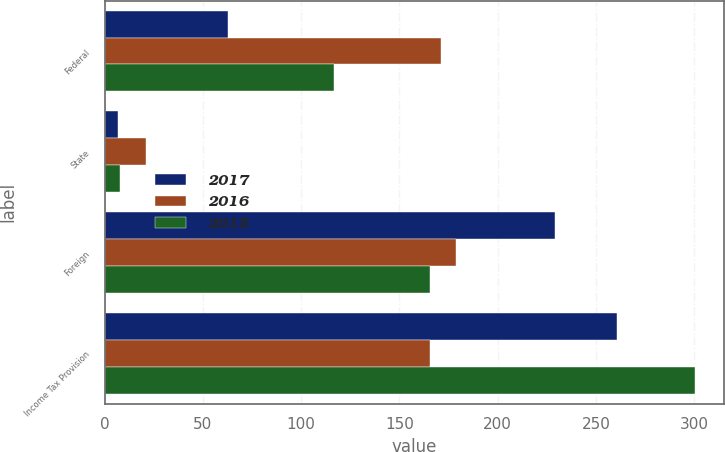Convert chart. <chart><loc_0><loc_0><loc_500><loc_500><stacked_bar_chart><ecel><fcel>Federal<fcel>State<fcel>Foreign<fcel>Income Tax Provision<nl><fcel>2017<fcel>62.8<fcel>7<fcel>229.1<fcel>260.9<nl><fcel>2016<fcel>171<fcel>21.2<fcel>178.6<fcel>165.7<nl><fcel>2015<fcel>117<fcel>8.1<fcel>165.7<fcel>300.2<nl></chart> 